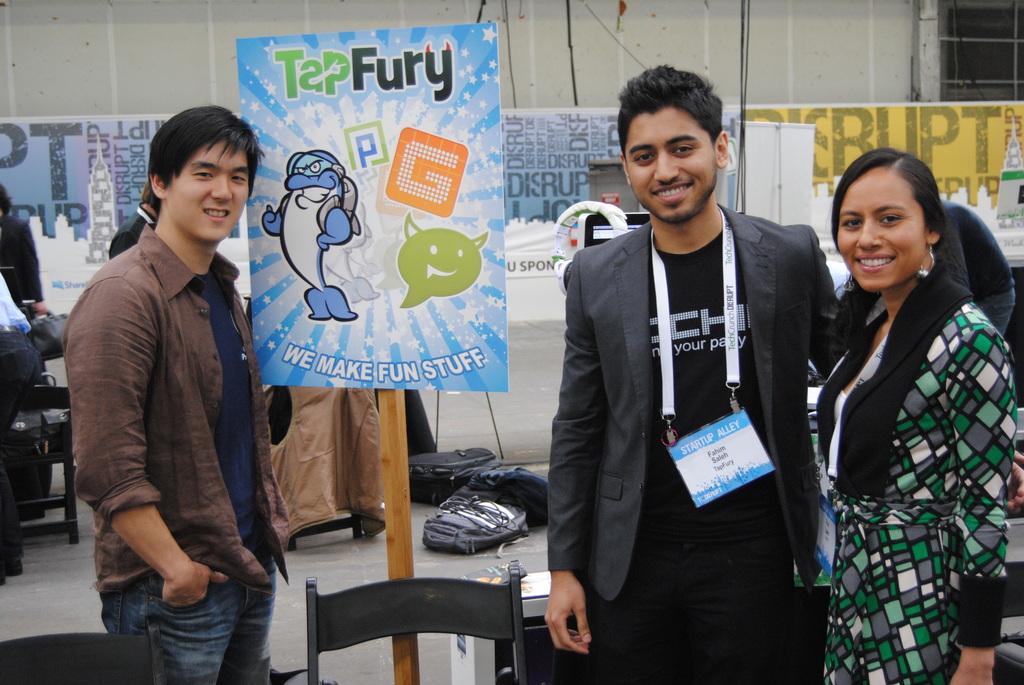Could you give a brief overview of what you see in this image? In this image we can see this people are standing. We can see a board, bags, chairs and banners in the background. 